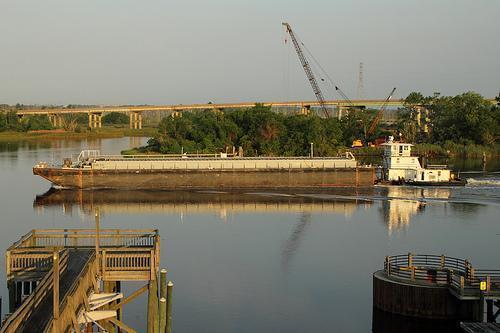How many cranes are in photo?
Give a very brief answer. 1. 